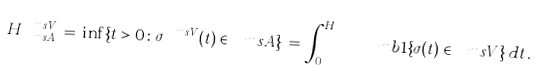<formula> <loc_0><loc_0><loc_500><loc_500>H ^ { \ m s V } _ { \ m s A } \, = \, \inf \{ t > 0 \colon \sigma ^ { \ m s V } ( t ) \in \ m s A \} \, = \, \int _ { 0 } ^ { H _ { \ m s A } } \ m b 1 \{ \sigma ( t ) \in \ m s V \} \, d t \, .</formula> 